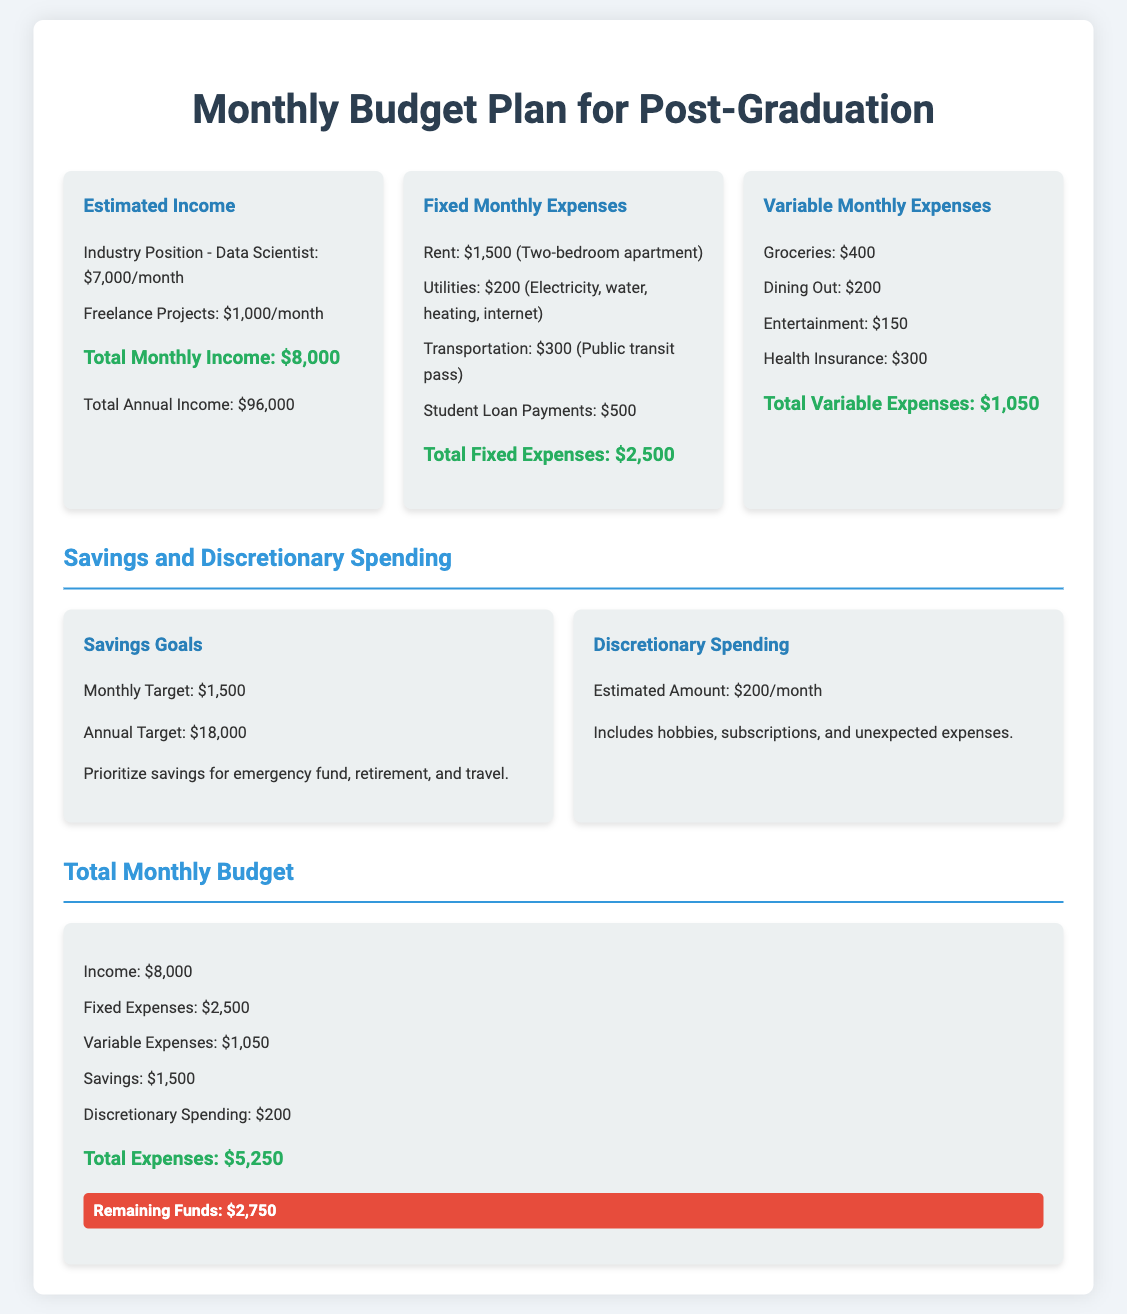What is the total monthly income? The total monthly income is the sum of the income from the industry position and freelance projects, which is $7,000 + $1,000 = $8,000.
Answer: $8,000 What is the total fixed monthly expenses? The total fixed monthly expenses is calculated by adding rent, utilities, transportation, and student loan payments, which totals $1,500 + $200 + $300 + $500 = $2,500.
Answer: $2,500 What is the monthly savings target? The monthly savings target is stated in the document as being prioritized for emergency funds, retirement, and travel, which is $1,500.
Answer: $1,500 How much is allocated for discretionary spending? The estimated amount for discretionary spending is directly stated in the document, which is $200 per month.
Answer: $200 What are the total variable expenses? The total variable expenses are found by summing up groceries, dining out, entertainment, and health insurance, amounting to $400 + $200 + $150 + $300 = $1,050.
Answer: $1,050 What is the remaining funds after total expenses? The remaining funds are calculated by subtracting total expenses from total income, where total expenses are $5,250 and total income is $8,000, leading to $8,000 - $5,250 = $2,750.
Answer: $2,750 What is the total annual income? The total annual income is derived by multiplying the total monthly income by twelve months, which is $8,000 * 12 = $96,000.
Answer: $96,000 Which position is listed as a source of income? The document lists the position of Data Scientist as a source of income along with freelance projects.
Answer: Data Scientist 